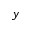<formula> <loc_0><loc_0><loc_500><loc_500>y</formula> 